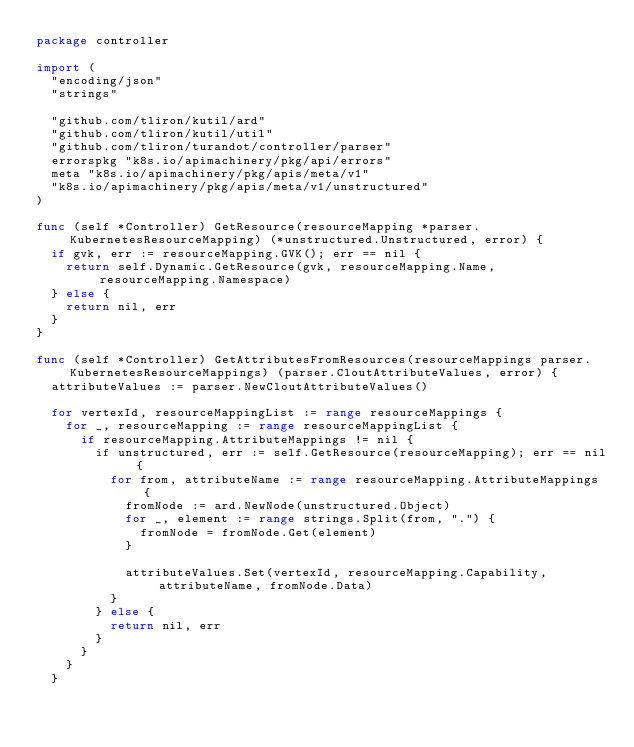<code> <loc_0><loc_0><loc_500><loc_500><_Go_>package controller

import (
	"encoding/json"
	"strings"

	"github.com/tliron/kutil/ard"
	"github.com/tliron/kutil/util"
	"github.com/tliron/turandot/controller/parser"
	errorspkg "k8s.io/apimachinery/pkg/api/errors"
	meta "k8s.io/apimachinery/pkg/apis/meta/v1"
	"k8s.io/apimachinery/pkg/apis/meta/v1/unstructured"
)

func (self *Controller) GetResource(resourceMapping *parser.KubernetesResourceMapping) (*unstructured.Unstructured, error) {
	if gvk, err := resourceMapping.GVK(); err == nil {
		return self.Dynamic.GetResource(gvk, resourceMapping.Name, resourceMapping.Namespace)
	} else {
		return nil, err
	}
}

func (self *Controller) GetAttributesFromResources(resourceMappings parser.KubernetesResourceMappings) (parser.CloutAttributeValues, error) {
	attributeValues := parser.NewCloutAttributeValues()

	for vertexId, resourceMappingList := range resourceMappings {
		for _, resourceMapping := range resourceMappingList {
			if resourceMapping.AttributeMappings != nil {
				if unstructured, err := self.GetResource(resourceMapping); err == nil {
					for from, attributeName := range resourceMapping.AttributeMappings {
						fromNode := ard.NewNode(unstructured.Object)
						for _, element := range strings.Split(from, ".") {
							fromNode = fromNode.Get(element)
						}

						attributeValues.Set(vertexId, resourceMapping.Capability, attributeName, fromNode.Data)
					}
				} else {
					return nil, err
				}
			}
		}
	}
</code> 